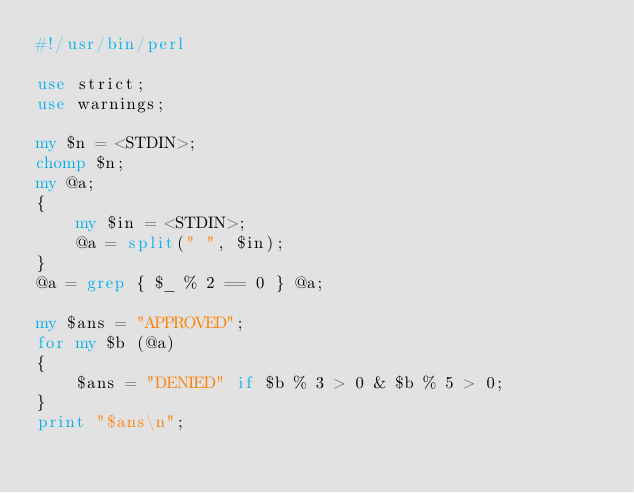<code> <loc_0><loc_0><loc_500><loc_500><_Perl_>#!/usr/bin/perl

use strict;
use warnings;

my $n = <STDIN>;
chomp $n;
my @a;
{
    my $in = <STDIN>;
    @a = split(" ", $in);
}
@a = grep { $_ % 2 == 0 } @a;

my $ans = "APPROVED";
for my $b (@a)
{
    $ans = "DENIED" if $b % 3 > 0 & $b % 5 > 0;
}
print "$ans\n";</code> 